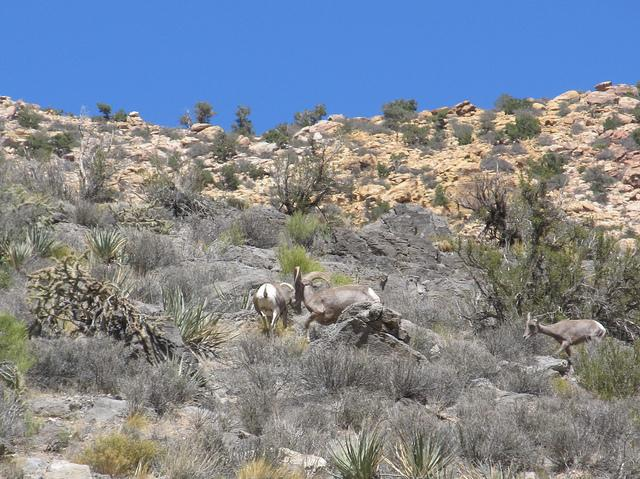What does the sky depict about the weather? sunny 